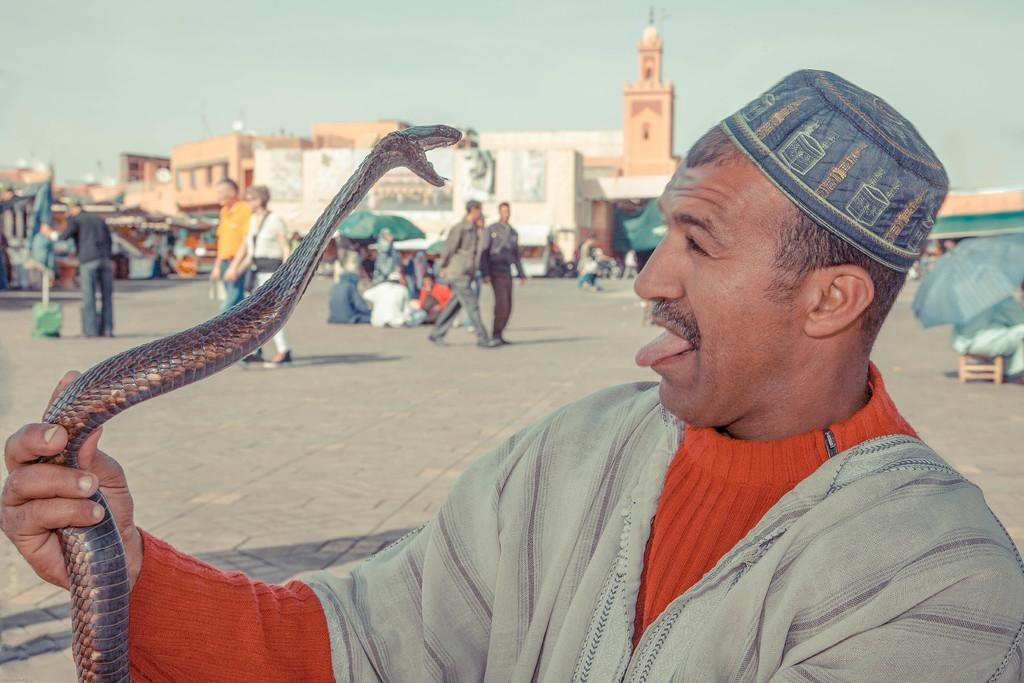Where was the image taken? The image was clicked outside the city. What is the man in the image holding? The man is holding a snake in the image. What can be seen in the background of the image? There are people sitting and walking, a fort, and the sky visible in the background of the image. What might be the purpose of the fort in the background? The fort in the background might serve as a historical or cultural landmark. Where are the dolls placed in the image? There are no dolls present in the image. What type of boundary can be seen in the image? There is no specific boundary visible in the image. 